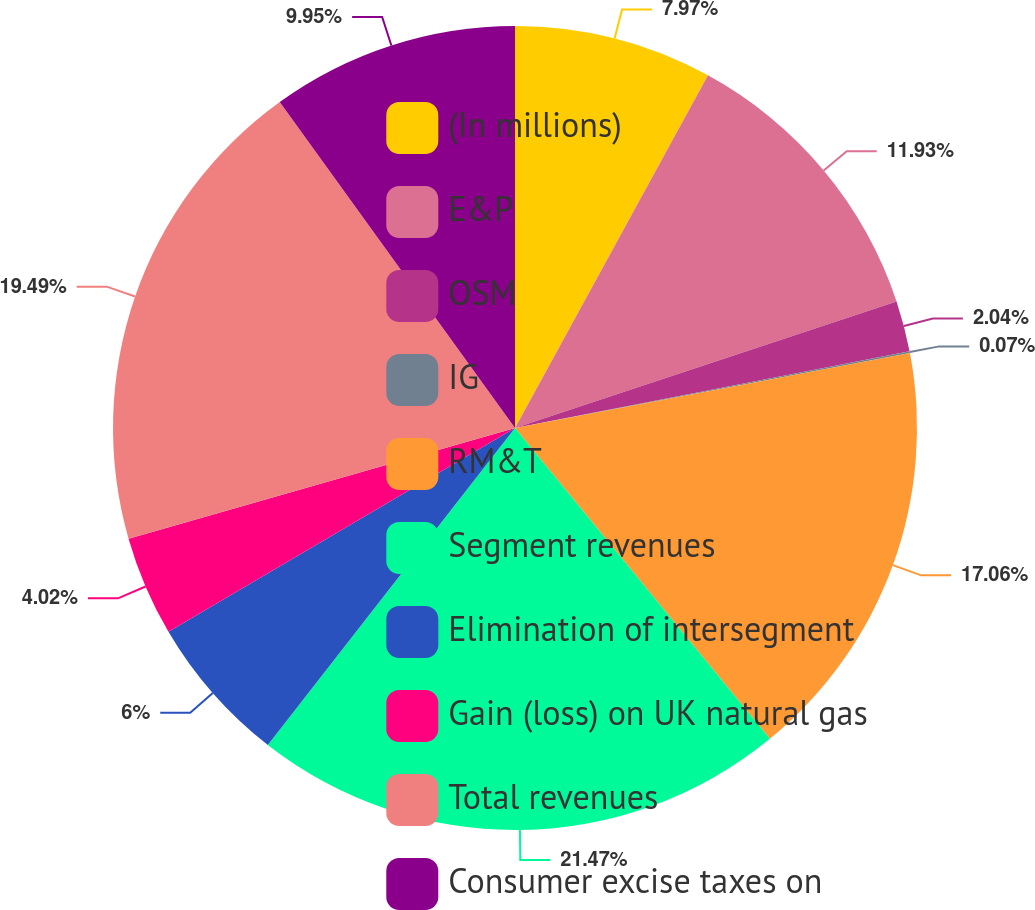<chart> <loc_0><loc_0><loc_500><loc_500><pie_chart><fcel>(In millions)<fcel>E&P<fcel>OSM<fcel>IG<fcel>RM&T<fcel>Segment revenues<fcel>Elimination of intersegment<fcel>Gain (loss) on UK natural gas<fcel>Total revenues<fcel>Consumer excise taxes on<nl><fcel>7.97%<fcel>11.93%<fcel>2.04%<fcel>0.07%<fcel>17.06%<fcel>21.47%<fcel>6.0%<fcel>4.02%<fcel>19.49%<fcel>9.95%<nl></chart> 